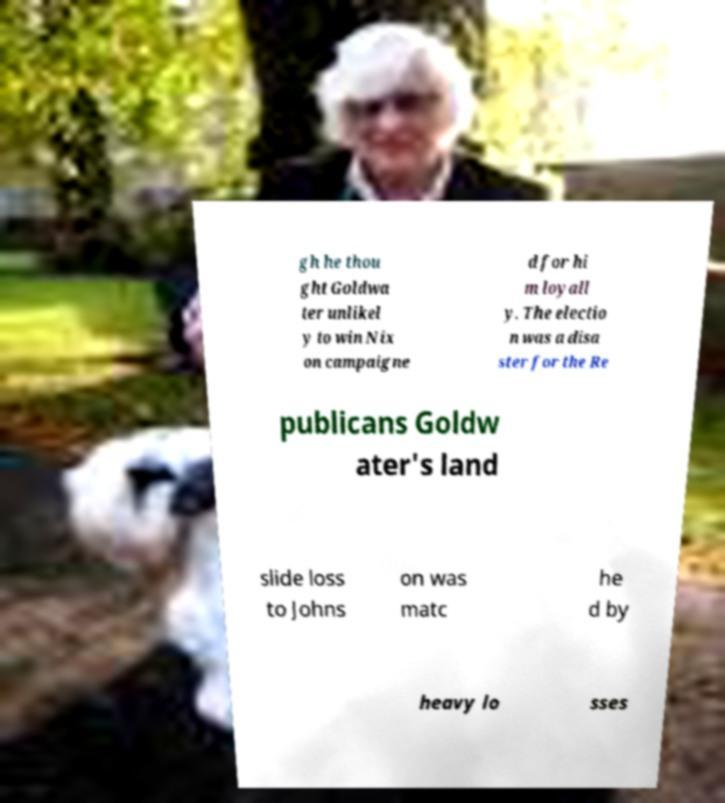Can you accurately transcribe the text from the provided image for me? gh he thou ght Goldwa ter unlikel y to win Nix on campaigne d for hi m loyall y. The electio n was a disa ster for the Re publicans Goldw ater's land slide loss to Johns on was matc he d by heavy lo sses 